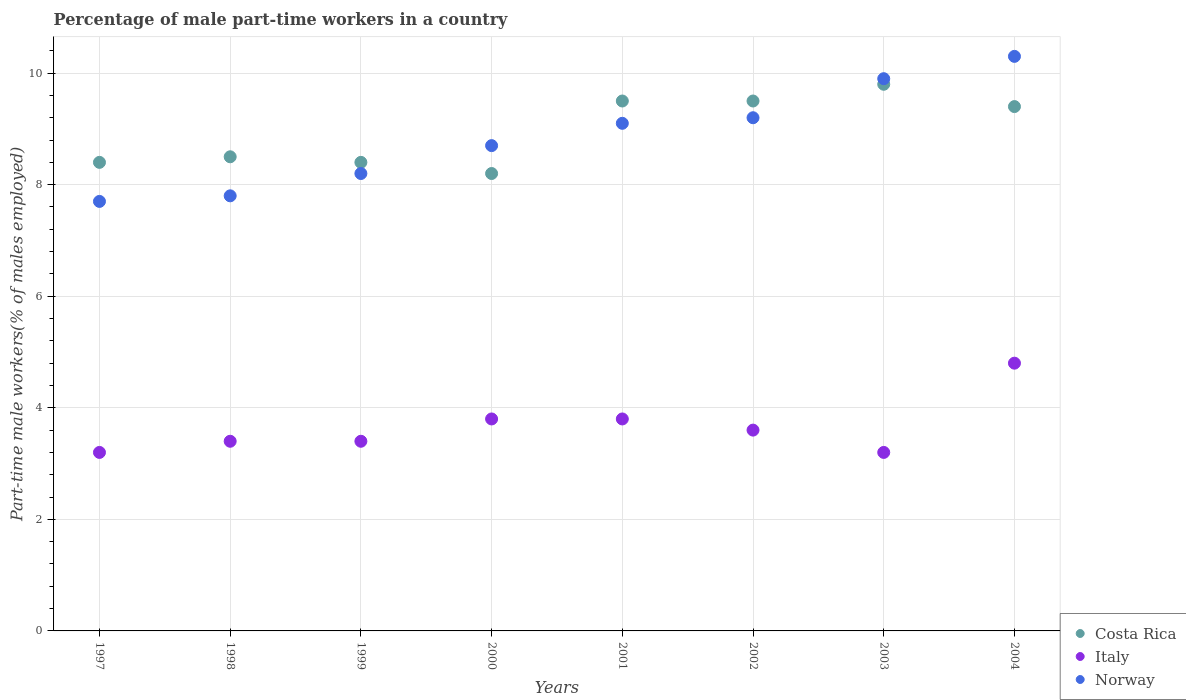Is the number of dotlines equal to the number of legend labels?
Your response must be concise. Yes. What is the percentage of male part-time workers in Italy in 1998?
Offer a terse response. 3.4. Across all years, what is the maximum percentage of male part-time workers in Costa Rica?
Offer a terse response. 9.8. Across all years, what is the minimum percentage of male part-time workers in Italy?
Offer a terse response. 3.2. What is the total percentage of male part-time workers in Norway in the graph?
Your answer should be very brief. 70.9. What is the difference between the percentage of male part-time workers in Costa Rica in 1999 and that in 2000?
Provide a short and direct response. 0.2. What is the difference between the percentage of male part-time workers in Italy in 1998 and the percentage of male part-time workers in Costa Rica in 2001?
Make the answer very short. -6.1. What is the average percentage of male part-time workers in Costa Rica per year?
Offer a very short reply. 8.96. In the year 2003, what is the difference between the percentage of male part-time workers in Costa Rica and percentage of male part-time workers in Norway?
Your response must be concise. -0.1. In how many years, is the percentage of male part-time workers in Italy greater than 3.2 %?
Your answer should be compact. 8. What is the ratio of the percentage of male part-time workers in Norway in 1997 to that in 2003?
Keep it short and to the point. 0.78. What is the difference between the highest and the second highest percentage of male part-time workers in Italy?
Make the answer very short. 1. What is the difference between the highest and the lowest percentage of male part-time workers in Norway?
Give a very brief answer. 2.6. Is it the case that in every year, the sum of the percentage of male part-time workers in Norway and percentage of male part-time workers in Costa Rica  is greater than the percentage of male part-time workers in Italy?
Ensure brevity in your answer.  Yes. Is the percentage of male part-time workers in Norway strictly greater than the percentage of male part-time workers in Costa Rica over the years?
Ensure brevity in your answer.  No. Is the percentage of male part-time workers in Costa Rica strictly less than the percentage of male part-time workers in Italy over the years?
Your answer should be very brief. No. How many dotlines are there?
Give a very brief answer. 3. How many years are there in the graph?
Ensure brevity in your answer.  8. What is the difference between two consecutive major ticks on the Y-axis?
Make the answer very short. 2. Are the values on the major ticks of Y-axis written in scientific E-notation?
Offer a very short reply. No. Does the graph contain grids?
Make the answer very short. Yes. How many legend labels are there?
Provide a short and direct response. 3. What is the title of the graph?
Ensure brevity in your answer.  Percentage of male part-time workers in a country. What is the label or title of the X-axis?
Give a very brief answer. Years. What is the label or title of the Y-axis?
Ensure brevity in your answer.  Part-time male workers(% of males employed). What is the Part-time male workers(% of males employed) of Costa Rica in 1997?
Keep it short and to the point. 8.4. What is the Part-time male workers(% of males employed) in Italy in 1997?
Keep it short and to the point. 3.2. What is the Part-time male workers(% of males employed) of Norway in 1997?
Provide a short and direct response. 7.7. What is the Part-time male workers(% of males employed) in Costa Rica in 1998?
Your answer should be very brief. 8.5. What is the Part-time male workers(% of males employed) of Italy in 1998?
Ensure brevity in your answer.  3.4. What is the Part-time male workers(% of males employed) of Norway in 1998?
Your response must be concise. 7.8. What is the Part-time male workers(% of males employed) of Costa Rica in 1999?
Ensure brevity in your answer.  8.4. What is the Part-time male workers(% of males employed) in Italy in 1999?
Ensure brevity in your answer.  3.4. What is the Part-time male workers(% of males employed) in Norway in 1999?
Provide a succinct answer. 8.2. What is the Part-time male workers(% of males employed) in Costa Rica in 2000?
Keep it short and to the point. 8.2. What is the Part-time male workers(% of males employed) of Italy in 2000?
Offer a very short reply. 3.8. What is the Part-time male workers(% of males employed) of Norway in 2000?
Offer a terse response. 8.7. What is the Part-time male workers(% of males employed) of Costa Rica in 2001?
Ensure brevity in your answer.  9.5. What is the Part-time male workers(% of males employed) in Italy in 2001?
Your answer should be compact. 3.8. What is the Part-time male workers(% of males employed) of Norway in 2001?
Ensure brevity in your answer.  9.1. What is the Part-time male workers(% of males employed) in Italy in 2002?
Your answer should be very brief. 3.6. What is the Part-time male workers(% of males employed) of Norway in 2002?
Offer a very short reply. 9.2. What is the Part-time male workers(% of males employed) in Costa Rica in 2003?
Offer a terse response. 9.8. What is the Part-time male workers(% of males employed) in Italy in 2003?
Your response must be concise. 3.2. What is the Part-time male workers(% of males employed) in Norway in 2003?
Offer a very short reply. 9.9. What is the Part-time male workers(% of males employed) of Costa Rica in 2004?
Give a very brief answer. 9.4. What is the Part-time male workers(% of males employed) of Italy in 2004?
Keep it short and to the point. 4.8. What is the Part-time male workers(% of males employed) in Norway in 2004?
Give a very brief answer. 10.3. Across all years, what is the maximum Part-time male workers(% of males employed) of Costa Rica?
Your answer should be very brief. 9.8. Across all years, what is the maximum Part-time male workers(% of males employed) of Italy?
Keep it short and to the point. 4.8. Across all years, what is the maximum Part-time male workers(% of males employed) in Norway?
Your response must be concise. 10.3. Across all years, what is the minimum Part-time male workers(% of males employed) of Costa Rica?
Provide a short and direct response. 8.2. Across all years, what is the minimum Part-time male workers(% of males employed) in Italy?
Provide a succinct answer. 3.2. Across all years, what is the minimum Part-time male workers(% of males employed) of Norway?
Keep it short and to the point. 7.7. What is the total Part-time male workers(% of males employed) of Costa Rica in the graph?
Keep it short and to the point. 71.7. What is the total Part-time male workers(% of males employed) of Italy in the graph?
Provide a short and direct response. 29.2. What is the total Part-time male workers(% of males employed) in Norway in the graph?
Keep it short and to the point. 70.9. What is the difference between the Part-time male workers(% of males employed) of Norway in 1997 and that in 1998?
Your response must be concise. -0.1. What is the difference between the Part-time male workers(% of males employed) in Norway in 1997 and that in 1999?
Ensure brevity in your answer.  -0.5. What is the difference between the Part-time male workers(% of males employed) in Costa Rica in 1997 and that in 2000?
Give a very brief answer. 0.2. What is the difference between the Part-time male workers(% of males employed) of Italy in 1997 and that in 2000?
Offer a terse response. -0.6. What is the difference between the Part-time male workers(% of males employed) in Costa Rica in 1997 and that in 2001?
Your answer should be compact. -1.1. What is the difference between the Part-time male workers(% of males employed) of Norway in 1997 and that in 2003?
Ensure brevity in your answer.  -2.2. What is the difference between the Part-time male workers(% of males employed) in Costa Rica in 1997 and that in 2004?
Your answer should be compact. -1. What is the difference between the Part-time male workers(% of males employed) of Norway in 1997 and that in 2004?
Give a very brief answer. -2.6. What is the difference between the Part-time male workers(% of males employed) in Norway in 1998 and that in 1999?
Your answer should be compact. -0.4. What is the difference between the Part-time male workers(% of males employed) of Costa Rica in 1998 and that in 2000?
Offer a very short reply. 0.3. What is the difference between the Part-time male workers(% of males employed) of Norway in 1998 and that in 2000?
Keep it short and to the point. -0.9. What is the difference between the Part-time male workers(% of males employed) in Italy in 1998 and that in 2001?
Give a very brief answer. -0.4. What is the difference between the Part-time male workers(% of males employed) in Norway in 1998 and that in 2001?
Your answer should be compact. -1.3. What is the difference between the Part-time male workers(% of males employed) of Costa Rica in 1998 and that in 2002?
Give a very brief answer. -1. What is the difference between the Part-time male workers(% of males employed) of Costa Rica in 1998 and that in 2003?
Keep it short and to the point. -1.3. What is the difference between the Part-time male workers(% of males employed) in Norway in 1998 and that in 2003?
Your response must be concise. -2.1. What is the difference between the Part-time male workers(% of males employed) in Costa Rica in 1998 and that in 2004?
Give a very brief answer. -0.9. What is the difference between the Part-time male workers(% of males employed) of Italy in 1998 and that in 2004?
Your response must be concise. -1.4. What is the difference between the Part-time male workers(% of males employed) of Norway in 1998 and that in 2004?
Provide a succinct answer. -2.5. What is the difference between the Part-time male workers(% of males employed) in Norway in 1999 and that in 2000?
Give a very brief answer. -0.5. What is the difference between the Part-time male workers(% of males employed) in Italy in 1999 and that in 2001?
Your answer should be very brief. -0.4. What is the difference between the Part-time male workers(% of males employed) of Costa Rica in 1999 and that in 2002?
Your answer should be very brief. -1.1. What is the difference between the Part-time male workers(% of males employed) of Norway in 1999 and that in 2002?
Your answer should be very brief. -1. What is the difference between the Part-time male workers(% of males employed) of Norway in 1999 and that in 2003?
Make the answer very short. -1.7. What is the difference between the Part-time male workers(% of males employed) in Italy in 1999 and that in 2004?
Keep it short and to the point. -1.4. What is the difference between the Part-time male workers(% of males employed) of Norway in 1999 and that in 2004?
Provide a succinct answer. -2.1. What is the difference between the Part-time male workers(% of males employed) in Costa Rica in 2000 and that in 2002?
Your answer should be very brief. -1.3. What is the difference between the Part-time male workers(% of males employed) in Italy in 2000 and that in 2002?
Offer a terse response. 0.2. What is the difference between the Part-time male workers(% of males employed) of Costa Rica in 2000 and that in 2004?
Offer a terse response. -1.2. What is the difference between the Part-time male workers(% of males employed) in Italy in 2000 and that in 2004?
Provide a succinct answer. -1. What is the difference between the Part-time male workers(% of males employed) in Costa Rica in 2001 and that in 2002?
Your response must be concise. 0. What is the difference between the Part-time male workers(% of males employed) in Norway in 2001 and that in 2002?
Offer a terse response. -0.1. What is the difference between the Part-time male workers(% of males employed) of Costa Rica in 2001 and that in 2003?
Give a very brief answer. -0.3. What is the difference between the Part-time male workers(% of males employed) of Italy in 2001 and that in 2003?
Provide a short and direct response. 0.6. What is the difference between the Part-time male workers(% of males employed) of Norway in 2001 and that in 2003?
Provide a succinct answer. -0.8. What is the difference between the Part-time male workers(% of males employed) in Costa Rica in 2001 and that in 2004?
Give a very brief answer. 0.1. What is the difference between the Part-time male workers(% of males employed) of Norway in 2001 and that in 2004?
Your response must be concise. -1.2. What is the difference between the Part-time male workers(% of males employed) of Costa Rica in 2002 and that in 2003?
Your answer should be compact. -0.3. What is the difference between the Part-time male workers(% of males employed) in Italy in 2002 and that in 2003?
Provide a short and direct response. 0.4. What is the difference between the Part-time male workers(% of males employed) in Italy in 2002 and that in 2004?
Your response must be concise. -1.2. What is the difference between the Part-time male workers(% of males employed) in Norway in 2002 and that in 2004?
Provide a short and direct response. -1.1. What is the difference between the Part-time male workers(% of males employed) of Italy in 2003 and that in 2004?
Your response must be concise. -1.6. What is the difference between the Part-time male workers(% of males employed) of Norway in 2003 and that in 2004?
Make the answer very short. -0.4. What is the difference between the Part-time male workers(% of males employed) in Costa Rica in 1997 and the Part-time male workers(% of males employed) in Norway in 1998?
Your response must be concise. 0.6. What is the difference between the Part-time male workers(% of males employed) in Italy in 1997 and the Part-time male workers(% of males employed) in Norway in 1998?
Your answer should be compact. -4.6. What is the difference between the Part-time male workers(% of males employed) in Costa Rica in 1997 and the Part-time male workers(% of males employed) in Italy in 1999?
Offer a terse response. 5. What is the difference between the Part-time male workers(% of males employed) in Costa Rica in 1997 and the Part-time male workers(% of males employed) in Norway in 1999?
Offer a very short reply. 0.2. What is the difference between the Part-time male workers(% of males employed) of Italy in 1997 and the Part-time male workers(% of males employed) of Norway in 1999?
Offer a terse response. -5. What is the difference between the Part-time male workers(% of males employed) in Costa Rica in 1997 and the Part-time male workers(% of males employed) in Italy in 2000?
Your answer should be very brief. 4.6. What is the difference between the Part-time male workers(% of males employed) of Italy in 1997 and the Part-time male workers(% of males employed) of Norway in 2001?
Give a very brief answer. -5.9. What is the difference between the Part-time male workers(% of males employed) of Italy in 1997 and the Part-time male workers(% of males employed) of Norway in 2002?
Your answer should be very brief. -6. What is the difference between the Part-time male workers(% of males employed) of Costa Rica in 1997 and the Part-time male workers(% of males employed) of Norway in 2003?
Give a very brief answer. -1.5. What is the difference between the Part-time male workers(% of males employed) of Italy in 1997 and the Part-time male workers(% of males employed) of Norway in 2003?
Your answer should be very brief. -6.7. What is the difference between the Part-time male workers(% of males employed) of Italy in 1997 and the Part-time male workers(% of males employed) of Norway in 2004?
Offer a terse response. -7.1. What is the difference between the Part-time male workers(% of males employed) in Costa Rica in 1998 and the Part-time male workers(% of males employed) in Norway in 2000?
Make the answer very short. -0.2. What is the difference between the Part-time male workers(% of males employed) in Italy in 1998 and the Part-time male workers(% of males employed) in Norway in 2000?
Ensure brevity in your answer.  -5.3. What is the difference between the Part-time male workers(% of males employed) in Costa Rica in 1998 and the Part-time male workers(% of males employed) in Italy in 2002?
Your answer should be very brief. 4.9. What is the difference between the Part-time male workers(% of males employed) in Costa Rica in 1998 and the Part-time male workers(% of males employed) in Italy in 2003?
Provide a short and direct response. 5.3. What is the difference between the Part-time male workers(% of males employed) in Costa Rica in 1998 and the Part-time male workers(% of males employed) in Norway in 2004?
Your answer should be very brief. -1.8. What is the difference between the Part-time male workers(% of males employed) of Italy in 1998 and the Part-time male workers(% of males employed) of Norway in 2004?
Keep it short and to the point. -6.9. What is the difference between the Part-time male workers(% of males employed) in Costa Rica in 1999 and the Part-time male workers(% of males employed) in Italy in 2000?
Ensure brevity in your answer.  4.6. What is the difference between the Part-time male workers(% of males employed) in Costa Rica in 1999 and the Part-time male workers(% of males employed) in Norway in 2000?
Keep it short and to the point. -0.3. What is the difference between the Part-time male workers(% of males employed) in Costa Rica in 1999 and the Part-time male workers(% of males employed) in Italy in 2001?
Give a very brief answer. 4.6. What is the difference between the Part-time male workers(% of males employed) in Costa Rica in 1999 and the Part-time male workers(% of males employed) in Italy in 2002?
Give a very brief answer. 4.8. What is the difference between the Part-time male workers(% of males employed) in Costa Rica in 1999 and the Part-time male workers(% of males employed) in Norway in 2002?
Offer a very short reply. -0.8. What is the difference between the Part-time male workers(% of males employed) of Costa Rica in 1999 and the Part-time male workers(% of males employed) of Italy in 2003?
Ensure brevity in your answer.  5.2. What is the difference between the Part-time male workers(% of males employed) of Costa Rica in 1999 and the Part-time male workers(% of males employed) of Italy in 2004?
Your response must be concise. 3.6. What is the difference between the Part-time male workers(% of males employed) of Italy in 1999 and the Part-time male workers(% of males employed) of Norway in 2004?
Provide a succinct answer. -6.9. What is the difference between the Part-time male workers(% of males employed) of Costa Rica in 2000 and the Part-time male workers(% of males employed) of Italy in 2001?
Your response must be concise. 4.4. What is the difference between the Part-time male workers(% of males employed) of Costa Rica in 2000 and the Part-time male workers(% of males employed) of Norway in 2001?
Your answer should be compact. -0.9. What is the difference between the Part-time male workers(% of males employed) in Italy in 2000 and the Part-time male workers(% of males employed) in Norway in 2001?
Make the answer very short. -5.3. What is the difference between the Part-time male workers(% of males employed) of Italy in 2000 and the Part-time male workers(% of males employed) of Norway in 2002?
Give a very brief answer. -5.4. What is the difference between the Part-time male workers(% of males employed) in Costa Rica in 2000 and the Part-time male workers(% of males employed) in Norway in 2003?
Keep it short and to the point. -1.7. What is the difference between the Part-time male workers(% of males employed) in Italy in 2000 and the Part-time male workers(% of males employed) in Norway in 2003?
Your response must be concise. -6.1. What is the difference between the Part-time male workers(% of males employed) of Costa Rica in 2000 and the Part-time male workers(% of males employed) of Italy in 2004?
Make the answer very short. 3.4. What is the difference between the Part-time male workers(% of males employed) in Italy in 2000 and the Part-time male workers(% of males employed) in Norway in 2004?
Offer a very short reply. -6.5. What is the difference between the Part-time male workers(% of males employed) in Costa Rica in 2001 and the Part-time male workers(% of males employed) in Italy in 2003?
Keep it short and to the point. 6.3. What is the difference between the Part-time male workers(% of males employed) of Costa Rica in 2001 and the Part-time male workers(% of males employed) of Norway in 2003?
Your answer should be very brief. -0.4. What is the difference between the Part-time male workers(% of males employed) of Costa Rica in 2001 and the Part-time male workers(% of males employed) of Italy in 2004?
Your answer should be very brief. 4.7. What is the difference between the Part-time male workers(% of males employed) in Costa Rica in 2001 and the Part-time male workers(% of males employed) in Norway in 2004?
Provide a short and direct response. -0.8. What is the difference between the Part-time male workers(% of males employed) in Costa Rica in 2002 and the Part-time male workers(% of males employed) in Italy in 2003?
Provide a succinct answer. 6.3. What is the difference between the Part-time male workers(% of males employed) of Italy in 2002 and the Part-time male workers(% of males employed) of Norway in 2003?
Ensure brevity in your answer.  -6.3. What is the difference between the Part-time male workers(% of males employed) in Costa Rica in 2002 and the Part-time male workers(% of males employed) in Italy in 2004?
Provide a succinct answer. 4.7. What is the difference between the Part-time male workers(% of males employed) of Costa Rica in 2002 and the Part-time male workers(% of males employed) of Norway in 2004?
Your answer should be compact. -0.8. What is the difference between the Part-time male workers(% of males employed) in Italy in 2003 and the Part-time male workers(% of males employed) in Norway in 2004?
Your answer should be very brief. -7.1. What is the average Part-time male workers(% of males employed) of Costa Rica per year?
Keep it short and to the point. 8.96. What is the average Part-time male workers(% of males employed) in Italy per year?
Your answer should be very brief. 3.65. What is the average Part-time male workers(% of males employed) in Norway per year?
Your response must be concise. 8.86. In the year 1997, what is the difference between the Part-time male workers(% of males employed) of Costa Rica and Part-time male workers(% of males employed) of Italy?
Provide a succinct answer. 5.2. In the year 1997, what is the difference between the Part-time male workers(% of males employed) of Costa Rica and Part-time male workers(% of males employed) of Norway?
Your response must be concise. 0.7. In the year 1998, what is the difference between the Part-time male workers(% of males employed) in Costa Rica and Part-time male workers(% of males employed) in Norway?
Your answer should be compact. 0.7. In the year 1998, what is the difference between the Part-time male workers(% of males employed) in Italy and Part-time male workers(% of males employed) in Norway?
Ensure brevity in your answer.  -4.4. In the year 1999, what is the difference between the Part-time male workers(% of males employed) in Costa Rica and Part-time male workers(% of males employed) in Norway?
Ensure brevity in your answer.  0.2. In the year 2000, what is the difference between the Part-time male workers(% of males employed) of Costa Rica and Part-time male workers(% of males employed) of Italy?
Your response must be concise. 4.4. In the year 2000, what is the difference between the Part-time male workers(% of males employed) in Costa Rica and Part-time male workers(% of males employed) in Norway?
Provide a short and direct response. -0.5. In the year 2001, what is the difference between the Part-time male workers(% of males employed) of Costa Rica and Part-time male workers(% of males employed) of Italy?
Offer a terse response. 5.7. In the year 2002, what is the difference between the Part-time male workers(% of males employed) in Costa Rica and Part-time male workers(% of males employed) in Italy?
Your response must be concise. 5.9. In the year 2002, what is the difference between the Part-time male workers(% of males employed) of Costa Rica and Part-time male workers(% of males employed) of Norway?
Give a very brief answer. 0.3. In the year 2002, what is the difference between the Part-time male workers(% of males employed) in Italy and Part-time male workers(% of males employed) in Norway?
Offer a terse response. -5.6. In the year 2004, what is the difference between the Part-time male workers(% of males employed) in Costa Rica and Part-time male workers(% of males employed) in Italy?
Give a very brief answer. 4.6. In the year 2004, what is the difference between the Part-time male workers(% of males employed) in Costa Rica and Part-time male workers(% of males employed) in Norway?
Offer a very short reply. -0.9. In the year 2004, what is the difference between the Part-time male workers(% of males employed) of Italy and Part-time male workers(% of males employed) of Norway?
Your answer should be very brief. -5.5. What is the ratio of the Part-time male workers(% of males employed) in Costa Rica in 1997 to that in 1998?
Provide a succinct answer. 0.99. What is the ratio of the Part-time male workers(% of males employed) of Norway in 1997 to that in 1998?
Provide a succinct answer. 0.99. What is the ratio of the Part-time male workers(% of males employed) of Costa Rica in 1997 to that in 1999?
Your answer should be compact. 1. What is the ratio of the Part-time male workers(% of males employed) of Norway in 1997 to that in 1999?
Keep it short and to the point. 0.94. What is the ratio of the Part-time male workers(% of males employed) in Costa Rica in 1997 to that in 2000?
Provide a short and direct response. 1.02. What is the ratio of the Part-time male workers(% of males employed) in Italy in 1997 to that in 2000?
Make the answer very short. 0.84. What is the ratio of the Part-time male workers(% of males employed) in Norway in 1997 to that in 2000?
Your answer should be compact. 0.89. What is the ratio of the Part-time male workers(% of males employed) in Costa Rica in 1997 to that in 2001?
Your answer should be very brief. 0.88. What is the ratio of the Part-time male workers(% of males employed) of Italy in 1997 to that in 2001?
Offer a very short reply. 0.84. What is the ratio of the Part-time male workers(% of males employed) of Norway in 1997 to that in 2001?
Keep it short and to the point. 0.85. What is the ratio of the Part-time male workers(% of males employed) in Costa Rica in 1997 to that in 2002?
Give a very brief answer. 0.88. What is the ratio of the Part-time male workers(% of males employed) of Norway in 1997 to that in 2002?
Your answer should be very brief. 0.84. What is the ratio of the Part-time male workers(% of males employed) of Italy in 1997 to that in 2003?
Your answer should be very brief. 1. What is the ratio of the Part-time male workers(% of males employed) in Norway in 1997 to that in 2003?
Your answer should be very brief. 0.78. What is the ratio of the Part-time male workers(% of males employed) of Costa Rica in 1997 to that in 2004?
Your answer should be very brief. 0.89. What is the ratio of the Part-time male workers(% of males employed) in Italy in 1997 to that in 2004?
Offer a very short reply. 0.67. What is the ratio of the Part-time male workers(% of males employed) in Norway in 1997 to that in 2004?
Your answer should be compact. 0.75. What is the ratio of the Part-time male workers(% of males employed) of Costa Rica in 1998 to that in 1999?
Provide a succinct answer. 1.01. What is the ratio of the Part-time male workers(% of males employed) of Italy in 1998 to that in 1999?
Keep it short and to the point. 1. What is the ratio of the Part-time male workers(% of males employed) in Norway in 1998 to that in 1999?
Offer a terse response. 0.95. What is the ratio of the Part-time male workers(% of males employed) in Costa Rica in 1998 to that in 2000?
Provide a succinct answer. 1.04. What is the ratio of the Part-time male workers(% of males employed) in Italy in 1998 to that in 2000?
Your answer should be very brief. 0.89. What is the ratio of the Part-time male workers(% of males employed) in Norway in 1998 to that in 2000?
Make the answer very short. 0.9. What is the ratio of the Part-time male workers(% of males employed) of Costa Rica in 1998 to that in 2001?
Your answer should be compact. 0.89. What is the ratio of the Part-time male workers(% of males employed) in Italy in 1998 to that in 2001?
Your answer should be very brief. 0.89. What is the ratio of the Part-time male workers(% of males employed) of Norway in 1998 to that in 2001?
Your answer should be very brief. 0.86. What is the ratio of the Part-time male workers(% of males employed) in Costa Rica in 1998 to that in 2002?
Your response must be concise. 0.89. What is the ratio of the Part-time male workers(% of males employed) in Norway in 1998 to that in 2002?
Offer a very short reply. 0.85. What is the ratio of the Part-time male workers(% of males employed) in Costa Rica in 1998 to that in 2003?
Your answer should be very brief. 0.87. What is the ratio of the Part-time male workers(% of males employed) of Italy in 1998 to that in 2003?
Give a very brief answer. 1.06. What is the ratio of the Part-time male workers(% of males employed) of Norway in 1998 to that in 2003?
Make the answer very short. 0.79. What is the ratio of the Part-time male workers(% of males employed) in Costa Rica in 1998 to that in 2004?
Your answer should be very brief. 0.9. What is the ratio of the Part-time male workers(% of males employed) in Italy in 1998 to that in 2004?
Ensure brevity in your answer.  0.71. What is the ratio of the Part-time male workers(% of males employed) of Norway in 1998 to that in 2004?
Your answer should be very brief. 0.76. What is the ratio of the Part-time male workers(% of males employed) of Costa Rica in 1999 to that in 2000?
Provide a succinct answer. 1.02. What is the ratio of the Part-time male workers(% of males employed) in Italy in 1999 to that in 2000?
Provide a short and direct response. 0.89. What is the ratio of the Part-time male workers(% of males employed) of Norway in 1999 to that in 2000?
Provide a short and direct response. 0.94. What is the ratio of the Part-time male workers(% of males employed) in Costa Rica in 1999 to that in 2001?
Keep it short and to the point. 0.88. What is the ratio of the Part-time male workers(% of males employed) of Italy in 1999 to that in 2001?
Provide a short and direct response. 0.89. What is the ratio of the Part-time male workers(% of males employed) of Norway in 1999 to that in 2001?
Offer a terse response. 0.9. What is the ratio of the Part-time male workers(% of males employed) in Costa Rica in 1999 to that in 2002?
Your answer should be very brief. 0.88. What is the ratio of the Part-time male workers(% of males employed) in Norway in 1999 to that in 2002?
Your answer should be very brief. 0.89. What is the ratio of the Part-time male workers(% of males employed) of Costa Rica in 1999 to that in 2003?
Offer a very short reply. 0.86. What is the ratio of the Part-time male workers(% of males employed) in Norway in 1999 to that in 2003?
Provide a succinct answer. 0.83. What is the ratio of the Part-time male workers(% of males employed) in Costa Rica in 1999 to that in 2004?
Your answer should be compact. 0.89. What is the ratio of the Part-time male workers(% of males employed) in Italy in 1999 to that in 2004?
Ensure brevity in your answer.  0.71. What is the ratio of the Part-time male workers(% of males employed) in Norway in 1999 to that in 2004?
Your response must be concise. 0.8. What is the ratio of the Part-time male workers(% of males employed) in Costa Rica in 2000 to that in 2001?
Your answer should be compact. 0.86. What is the ratio of the Part-time male workers(% of males employed) of Norway in 2000 to that in 2001?
Provide a succinct answer. 0.96. What is the ratio of the Part-time male workers(% of males employed) in Costa Rica in 2000 to that in 2002?
Provide a short and direct response. 0.86. What is the ratio of the Part-time male workers(% of males employed) in Italy in 2000 to that in 2002?
Offer a very short reply. 1.06. What is the ratio of the Part-time male workers(% of males employed) of Norway in 2000 to that in 2002?
Your response must be concise. 0.95. What is the ratio of the Part-time male workers(% of males employed) of Costa Rica in 2000 to that in 2003?
Your answer should be very brief. 0.84. What is the ratio of the Part-time male workers(% of males employed) of Italy in 2000 to that in 2003?
Provide a succinct answer. 1.19. What is the ratio of the Part-time male workers(% of males employed) in Norway in 2000 to that in 2003?
Your answer should be very brief. 0.88. What is the ratio of the Part-time male workers(% of males employed) in Costa Rica in 2000 to that in 2004?
Ensure brevity in your answer.  0.87. What is the ratio of the Part-time male workers(% of males employed) of Italy in 2000 to that in 2004?
Provide a succinct answer. 0.79. What is the ratio of the Part-time male workers(% of males employed) in Norway in 2000 to that in 2004?
Give a very brief answer. 0.84. What is the ratio of the Part-time male workers(% of males employed) in Italy in 2001 to that in 2002?
Your answer should be very brief. 1.06. What is the ratio of the Part-time male workers(% of males employed) of Norway in 2001 to that in 2002?
Give a very brief answer. 0.99. What is the ratio of the Part-time male workers(% of males employed) in Costa Rica in 2001 to that in 2003?
Provide a succinct answer. 0.97. What is the ratio of the Part-time male workers(% of males employed) of Italy in 2001 to that in 2003?
Your answer should be compact. 1.19. What is the ratio of the Part-time male workers(% of males employed) in Norway in 2001 to that in 2003?
Your answer should be compact. 0.92. What is the ratio of the Part-time male workers(% of males employed) in Costa Rica in 2001 to that in 2004?
Your answer should be compact. 1.01. What is the ratio of the Part-time male workers(% of males employed) in Italy in 2001 to that in 2004?
Offer a very short reply. 0.79. What is the ratio of the Part-time male workers(% of males employed) in Norway in 2001 to that in 2004?
Make the answer very short. 0.88. What is the ratio of the Part-time male workers(% of males employed) of Costa Rica in 2002 to that in 2003?
Your answer should be compact. 0.97. What is the ratio of the Part-time male workers(% of males employed) in Norway in 2002 to that in 2003?
Give a very brief answer. 0.93. What is the ratio of the Part-time male workers(% of males employed) in Costa Rica in 2002 to that in 2004?
Provide a succinct answer. 1.01. What is the ratio of the Part-time male workers(% of males employed) of Norway in 2002 to that in 2004?
Give a very brief answer. 0.89. What is the ratio of the Part-time male workers(% of males employed) of Costa Rica in 2003 to that in 2004?
Keep it short and to the point. 1.04. What is the ratio of the Part-time male workers(% of males employed) of Italy in 2003 to that in 2004?
Your answer should be very brief. 0.67. What is the ratio of the Part-time male workers(% of males employed) of Norway in 2003 to that in 2004?
Your answer should be very brief. 0.96. What is the difference between the highest and the second highest Part-time male workers(% of males employed) of Costa Rica?
Offer a very short reply. 0.3. What is the difference between the highest and the second highest Part-time male workers(% of males employed) in Italy?
Provide a succinct answer. 1. What is the difference between the highest and the second highest Part-time male workers(% of males employed) in Norway?
Make the answer very short. 0.4. What is the difference between the highest and the lowest Part-time male workers(% of males employed) in Costa Rica?
Your response must be concise. 1.6. What is the difference between the highest and the lowest Part-time male workers(% of males employed) of Norway?
Give a very brief answer. 2.6. 